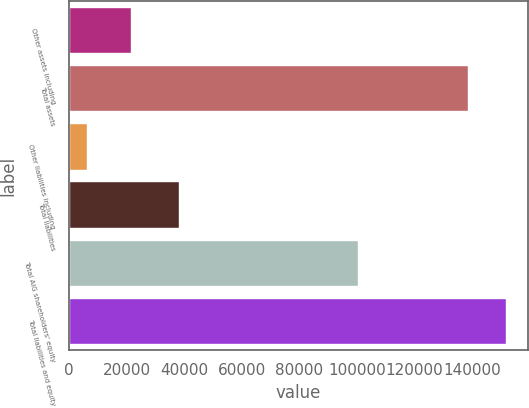Convert chart. <chart><loc_0><loc_0><loc_500><loc_500><bar_chart><fcel>Other assets including<fcel>Total assets<fcel>Other liabilities including<fcel>Total liabilities<fcel>Total AIG shareholders' equity<fcel>Total liabilities and equity<nl><fcel>21606<fcel>138583<fcel>6422<fcel>38113<fcel>100470<fcel>151799<nl></chart> 